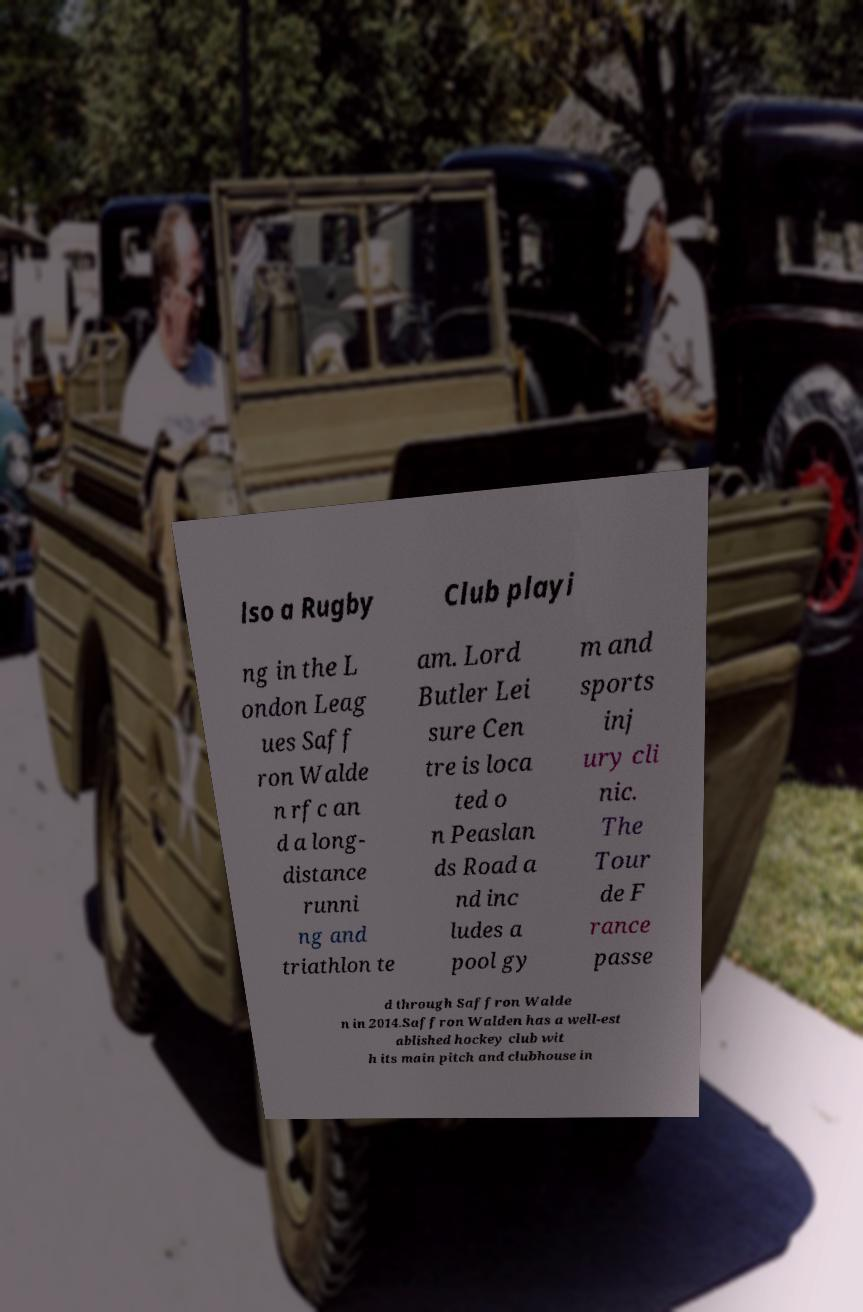Could you extract and type out the text from this image? lso a Rugby Club playi ng in the L ondon Leag ues Saff ron Walde n rfc an d a long- distance runni ng and triathlon te am. Lord Butler Lei sure Cen tre is loca ted o n Peaslan ds Road a nd inc ludes a pool gy m and sports inj ury cli nic. The Tour de F rance passe d through Saffron Walde n in 2014.Saffron Walden has a well-est ablished hockey club wit h its main pitch and clubhouse in 